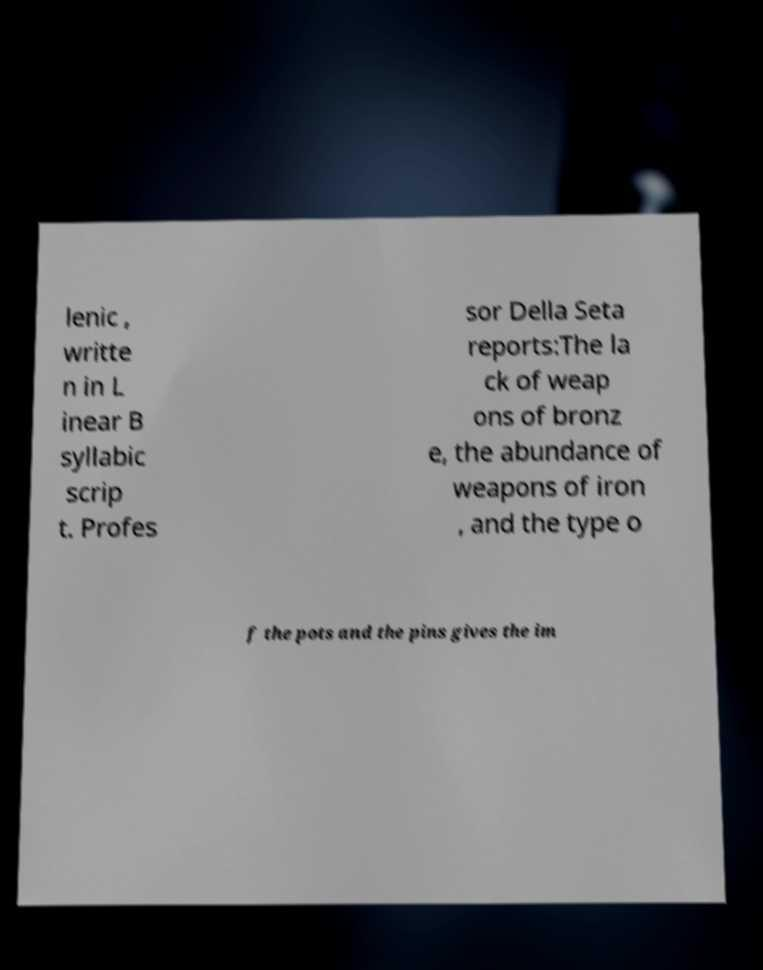Could you extract and type out the text from this image? lenic , writte n in L inear B syllabic scrip t. Profes sor Della Seta reports:The la ck of weap ons of bronz e, the abundance of weapons of iron , and the type o f the pots and the pins gives the im 